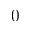<formula> <loc_0><loc_0><loc_500><loc_500>0</formula> 